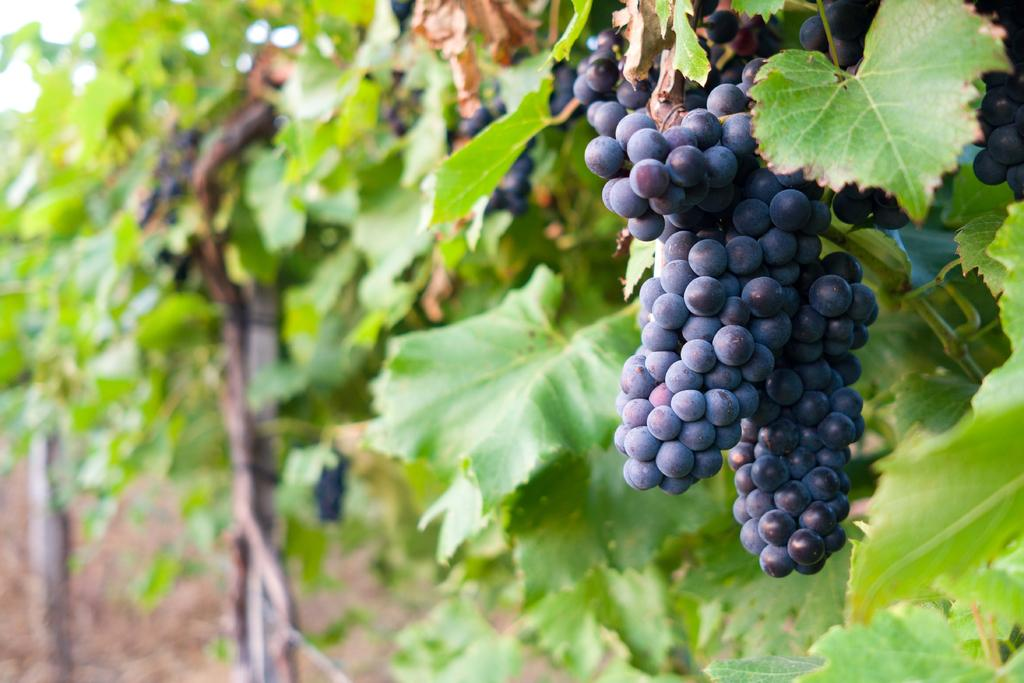What type of fruit can be seen in the image? There are grapes in the image. What other objects or living organisms are present in the image? There are plants in the image. What type of shade is provided by the grapes in the image? There is no shade provided by the grapes in the image, as they are not large enough to create shade. 